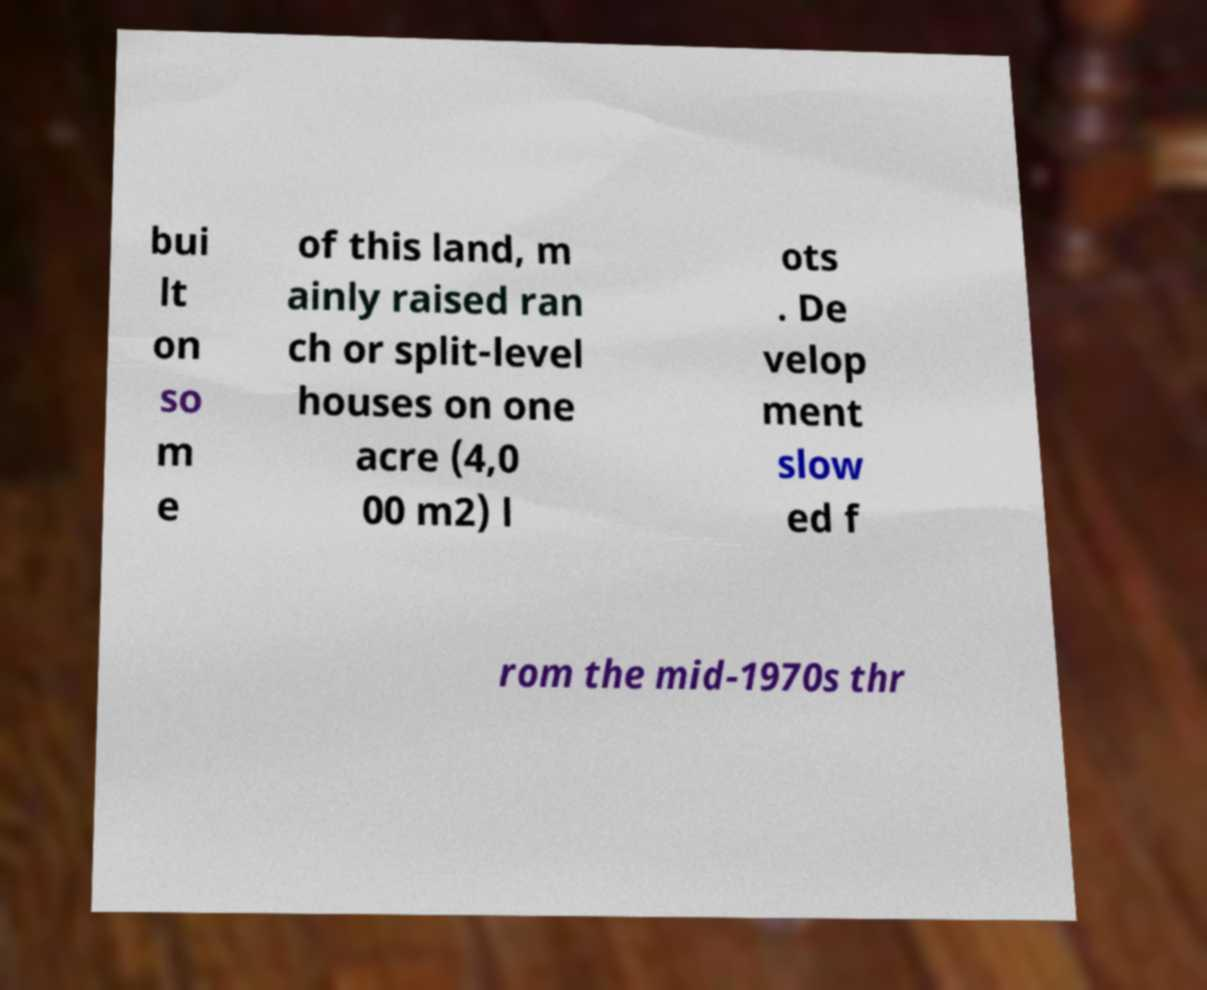There's text embedded in this image that I need extracted. Can you transcribe it verbatim? bui lt on so m e of this land, m ainly raised ran ch or split-level houses on one acre (4,0 00 m2) l ots . De velop ment slow ed f rom the mid-1970s thr 